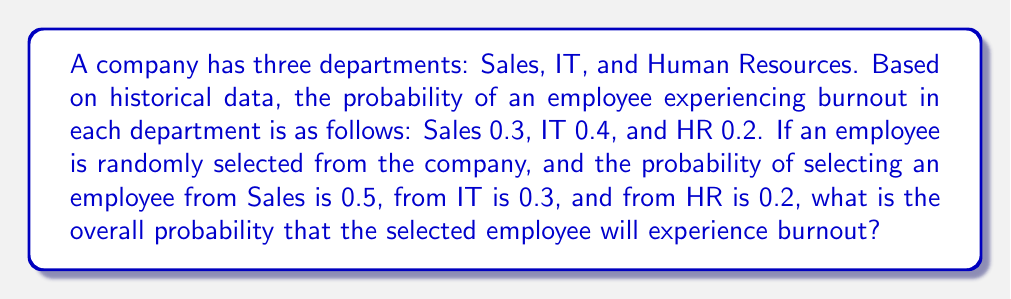Can you answer this question? To solve this problem, we'll use the law of total probability. Let's break it down step-by-step:

1) Let B be the event of an employee experiencing burnout.
   Let S, I, and H represent the events of selecting an employee from Sales, IT, and HR respectively.

2) We're given:
   $P(B|S) = 0.3$
   $P(B|I) = 0.4$
   $P(B|H) = 0.2$
   $P(S) = 0.5$
   $P(I) = 0.3$
   $P(H) = 0.2$

3) The law of total probability states:
   $P(B) = P(B|S)P(S) + P(B|I)P(I) + P(B|H)P(H)$

4) Substituting the values:
   $P(B) = (0.3)(0.5) + (0.4)(0.3) + (0.2)(0.2)$

5) Calculating:
   $P(B) = 0.15 + 0.12 + 0.04$

6) Adding these probabilities:
   $P(B) = 0.31$

Therefore, the overall probability that a randomly selected employee will experience burnout is 0.31 or 31%.
Answer: 0.31 